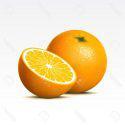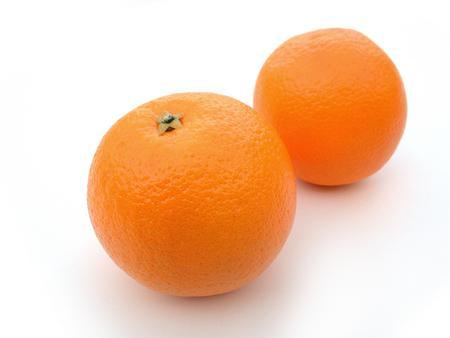The first image is the image on the left, the second image is the image on the right. Analyze the images presented: Is the assertion "There are four uncut oranges." valid? Answer yes or no. No. The first image is the image on the left, the second image is the image on the right. Assess this claim about the two images: "In total, the images contain the equivalent of four oranges.". Correct or not? Answer yes or no. No. 